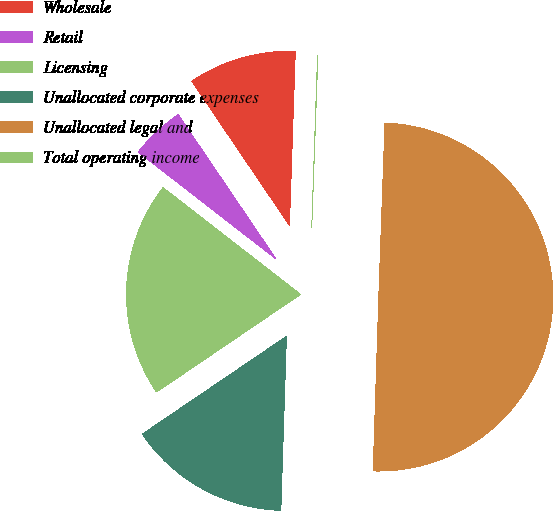Convert chart. <chart><loc_0><loc_0><loc_500><loc_500><pie_chart><fcel>Wholesale<fcel>Retail<fcel>Licensing<fcel>Unallocated corporate expenses<fcel>Unallocated legal and<fcel>Total operating income<nl><fcel>10.01%<fcel>5.02%<fcel>19.99%<fcel>15.0%<fcel>49.94%<fcel>0.03%<nl></chart> 